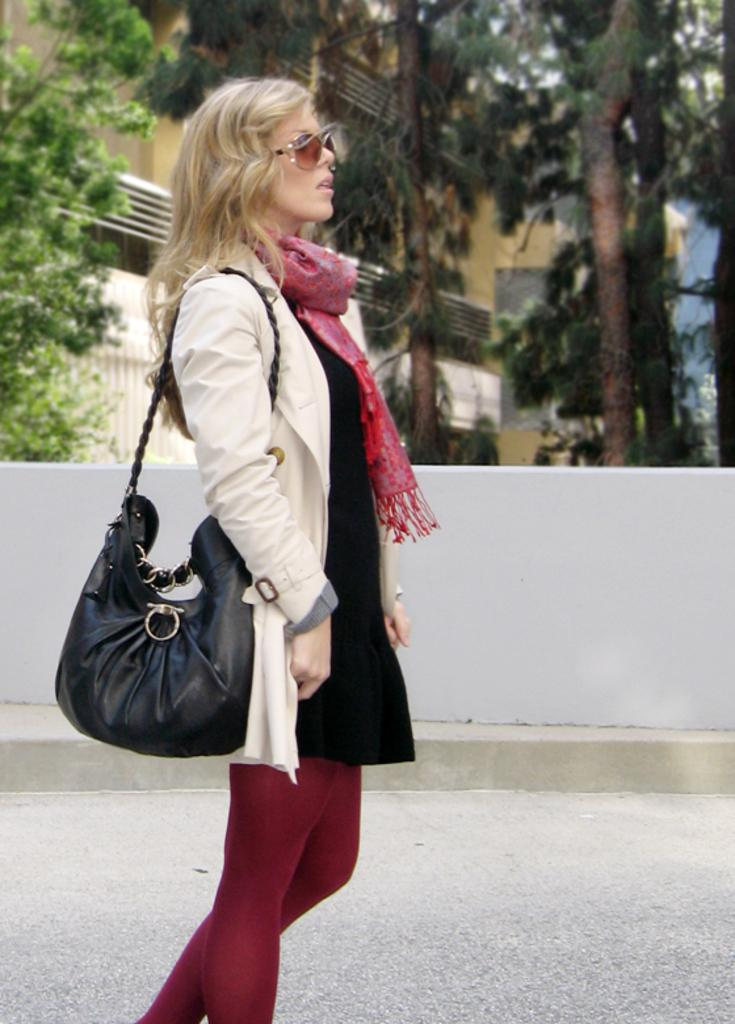What is the main subject of the image? There is a woman standing in the image. What is the woman holding in the image? The woman is holding a handbag. On which side of the image is the woman located? The woman is on the left side of the image. What can be seen in the background of the image? There is a wall in the background of the image. What type of vegetation is visible at the top of the image? There are trees visible at the top of the image. How many boys are playing with the doll in the image? There are no boys or dolls present in the image; it features a woman standing with a handbag. What type of place is depicted in the image? The image does not depict a specific place; it only shows a woman standing with a handbag against a background with a wall and trees. 